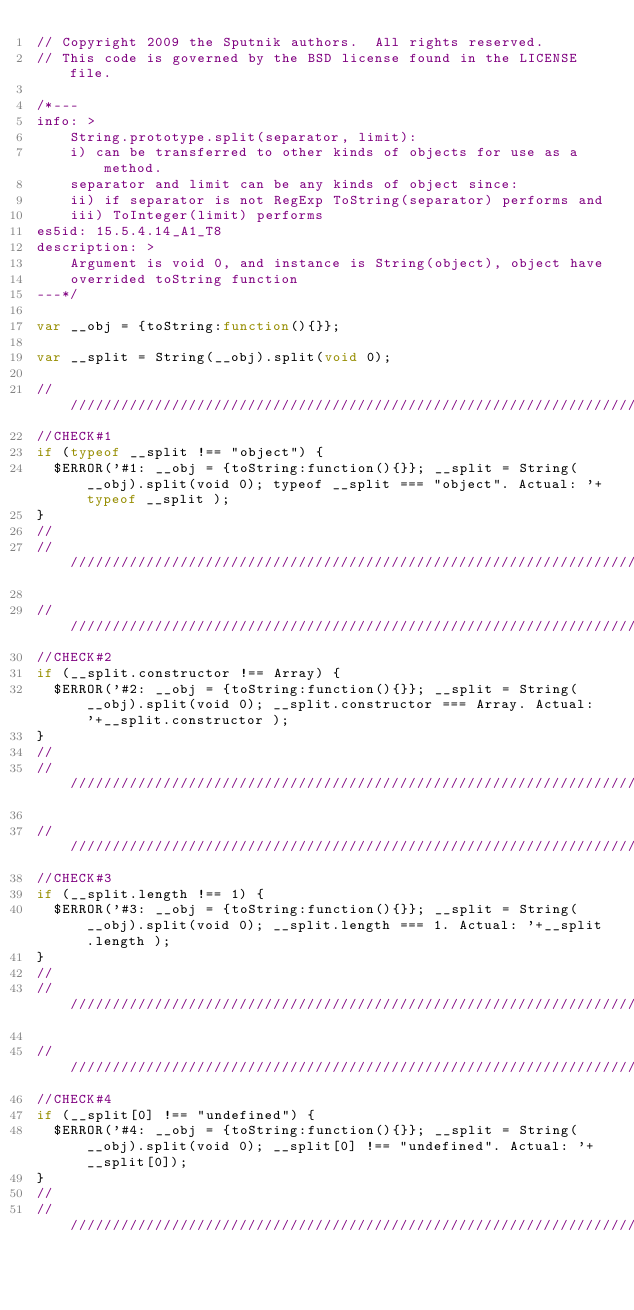Convert code to text. <code><loc_0><loc_0><loc_500><loc_500><_JavaScript_>// Copyright 2009 the Sputnik authors.  All rights reserved.
// This code is governed by the BSD license found in the LICENSE file.

/*---
info: >
    String.prototype.split(separator, limit):
    i) can be transferred to other kinds of objects for use as a method.
    separator and limit can be any kinds of object since:
    ii) if separator is not RegExp ToString(separator) performs and
    iii) ToInteger(limit) performs
es5id: 15.5.4.14_A1_T8
description: >
    Argument is void 0, and instance is String(object), object have
    overrided toString function
---*/

var __obj = {toString:function(){}};

var __split = String(__obj).split(void 0);

//////////////////////////////////////////////////////////////////////////////
//CHECK#1
if (typeof __split !== "object") {
  $ERROR('#1: __obj = {toString:function(){}}; __split = String(__obj).split(void 0); typeof __split === "object". Actual: '+typeof __split );
}
//
//////////////////////////////////////////////////////////////////////////////

//////////////////////////////////////////////////////////////////////////////
//CHECK#2
if (__split.constructor !== Array) {
  $ERROR('#2: __obj = {toString:function(){}}; __split = String(__obj).split(void 0); __split.constructor === Array. Actual: '+__split.constructor );
}
//
//////////////////////////////////////////////////////////////////////////////

//////////////////////////////////////////////////////////////////////////////
//CHECK#3
if (__split.length !== 1) {
  $ERROR('#3: __obj = {toString:function(){}}; __split = String(__obj).split(void 0); __split.length === 1. Actual: '+__split.length );
}
//
//////////////////////////////////////////////////////////////////////////////

//////////////////////////////////////////////////////////////////////////////
//CHECK#4
if (__split[0] !== "undefined") {
  $ERROR('#4: __obj = {toString:function(){}}; __split = String(__obj).split(void 0); __split[0] !== "undefined". Actual: '+__split[0]);
}
//
//////////////////////////////////////////////////////////////////////////////
</code> 